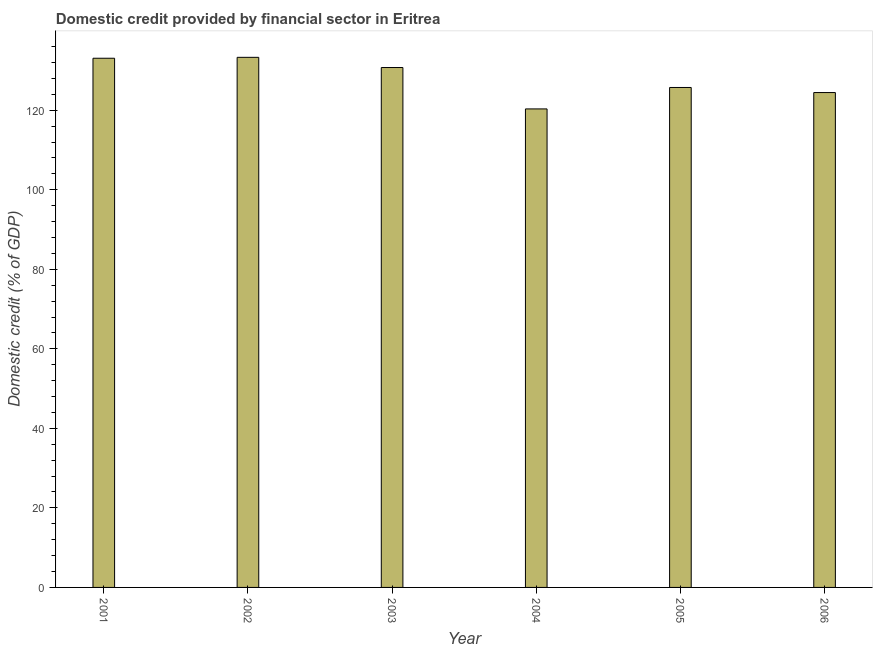Does the graph contain any zero values?
Your answer should be compact. No. What is the title of the graph?
Keep it short and to the point. Domestic credit provided by financial sector in Eritrea. What is the label or title of the Y-axis?
Give a very brief answer. Domestic credit (% of GDP). What is the domestic credit provided by financial sector in 2006?
Your response must be concise. 124.45. Across all years, what is the maximum domestic credit provided by financial sector?
Give a very brief answer. 133.31. Across all years, what is the minimum domestic credit provided by financial sector?
Give a very brief answer. 120.34. In which year was the domestic credit provided by financial sector maximum?
Give a very brief answer. 2002. What is the sum of the domestic credit provided by financial sector?
Keep it short and to the point. 767.64. What is the difference between the domestic credit provided by financial sector in 2002 and 2003?
Offer a very short reply. 2.56. What is the average domestic credit provided by financial sector per year?
Your answer should be compact. 127.94. What is the median domestic credit provided by financial sector?
Your response must be concise. 128.24. In how many years, is the domestic credit provided by financial sector greater than 8 %?
Offer a very short reply. 6. Do a majority of the years between 2002 and 2003 (inclusive) have domestic credit provided by financial sector greater than 100 %?
Your answer should be very brief. Yes. Is the difference between the domestic credit provided by financial sector in 2001 and 2003 greater than the difference between any two years?
Your answer should be very brief. No. What is the difference between the highest and the second highest domestic credit provided by financial sector?
Give a very brief answer. 0.23. Is the sum of the domestic credit provided by financial sector in 2001 and 2006 greater than the maximum domestic credit provided by financial sector across all years?
Make the answer very short. Yes. What is the difference between the highest and the lowest domestic credit provided by financial sector?
Provide a short and direct response. 12.97. How many bars are there?
Offer a terse response. 6. Are all the bars in the graph horizontal?
Keep it short and to the point. No. How many years are there in the graph?
Give a very brief answer. 6. What is the Domestic credit (% of GDP) of 2001?
Provide a short and direct response. 133.08. What is the Domestic credit (% of GDP) in 2002?
Your response must be concise. 133.31. What is the Domestic credit (% of GDP) of 2003?
Your answer should be very brief. 130.74. What is the Domestic credit (% of GDP) in 2004?
Make the answer very short. 120.34. What is the Domestic credit (% of GDP) in 2005?
Your answer should be compact. 125.73. What is the Domestic credit (% of GDP) of 2006?
Offer a terse response. 124.45. What is the difference between the Domestic credit (% of GDP) in 2001 and 2002?
Your answer should be very brief. -0.23. What is the difference between the Domestic credit (% of GDP) in 2001 and 2003?
Provide a succinct answer. 2.33. What is the difference between the Domestic credit (% of GDP) in 2001 and 2004?
Your answer should be very brief. 12.74. What is the difference between the Domestic credit (% of GDP) in 2001 and 2005?
Your answer should be very brief. 7.35. What is the difference between the Domestic credit (% of GDP) in 2001 and 2006?
Provide a succinct answer. 8.63. What is the difference between the Domestic credit (% of GDP) in 2002 and 2003?
Your response must be concise. 2.56. What is the difference between the Domestic credit (% of GDP) in 2002 and 2004?
Give a very brief answer. 12.97. What is the difference between the Domestic credit (% of GDP) in 2002 and 2005?
Make the answer very short. 7.58. What is the difference between the Domestic credit (% of GDP) in 2002 and 2006?
Your answer should be very brief. 8.86. What is the difference between the Domestic credit (% of GDP) in 2003 and 2004?
Your answer should be compact. 10.41. What is the difference between the Domestic credit (% of GDP) in 2003 and 2005?
Your answer should be very brief. 5.02. What is the difference between the Domestic credit (% of GDP) in 2003 and 2006?
Your response must be concise. 6.29. What is the difference between the Domestic credit (% of GDP) in 2004 and 2005?
Ensure brevity in your answer.  -5.39. What is the difference between the Domestic credit (% of GDP) in 2004 and 2006?
Give a very brief answer. -4.11. What is the difference between the Domestic credit (% of GDP) in 2005 and 2006?
Your response must be concise. 1.28. What is the ratio of the Domestic credit (% of GDP) in 2001 to that in 2002?
Provide a succinct answer. 1. What is the ratio of the Domestic credit (% of GDP) in 2001 to that in 2003?
Keep it short and to the point. 1.02. What is the ratio of the Domestic credit (% of GDP) in 2001 to that in 2004?
Provide a succinct answer. 1.11. What is the ratio of the Domestic credit (% of GDP) in 2001 to that in 2005?
Make the answer very short. 1.06. What is the ratio of the Domestic credit (% of GDP) in 2001 to that in 2006?
Provide a succinct answer. 1.07. What is the ratio of the Domestic credit (% of GDP) in 2002 to that in 2003?
Your answer should be compact. 1.02. What is the ratio of the Domestic credit (% of GDP) in 2002 to that in 2004?
Provide a succinct answer. 1.11. What is the ratio of the Domestic credit (% of GDP) in 2002 to that in 2005?
Your answer should be very brief. 1.06. What is the ratio of the Domestic credit (% of GDP) in 2002 to that in 2006?
Your answer should be very brief. 1.07. What is the ratio of the Domestic credit (% of GDP) in 2003 to that in 2004?
Offer a terse response. 1.09. What is the ratio of the Domestic credit (% of GDP) in 2003 to that in 2006?
Make the answer very short. 1.05. What is the ratio of the Domestic credit (% of GDP) in 2004 to that in 2005?
Your response must be concise. 0.96. What is the ratio of the Domestic credit (% of GDP) in 2004 to that in 2006?
Your answer should be compact. 0.97. 